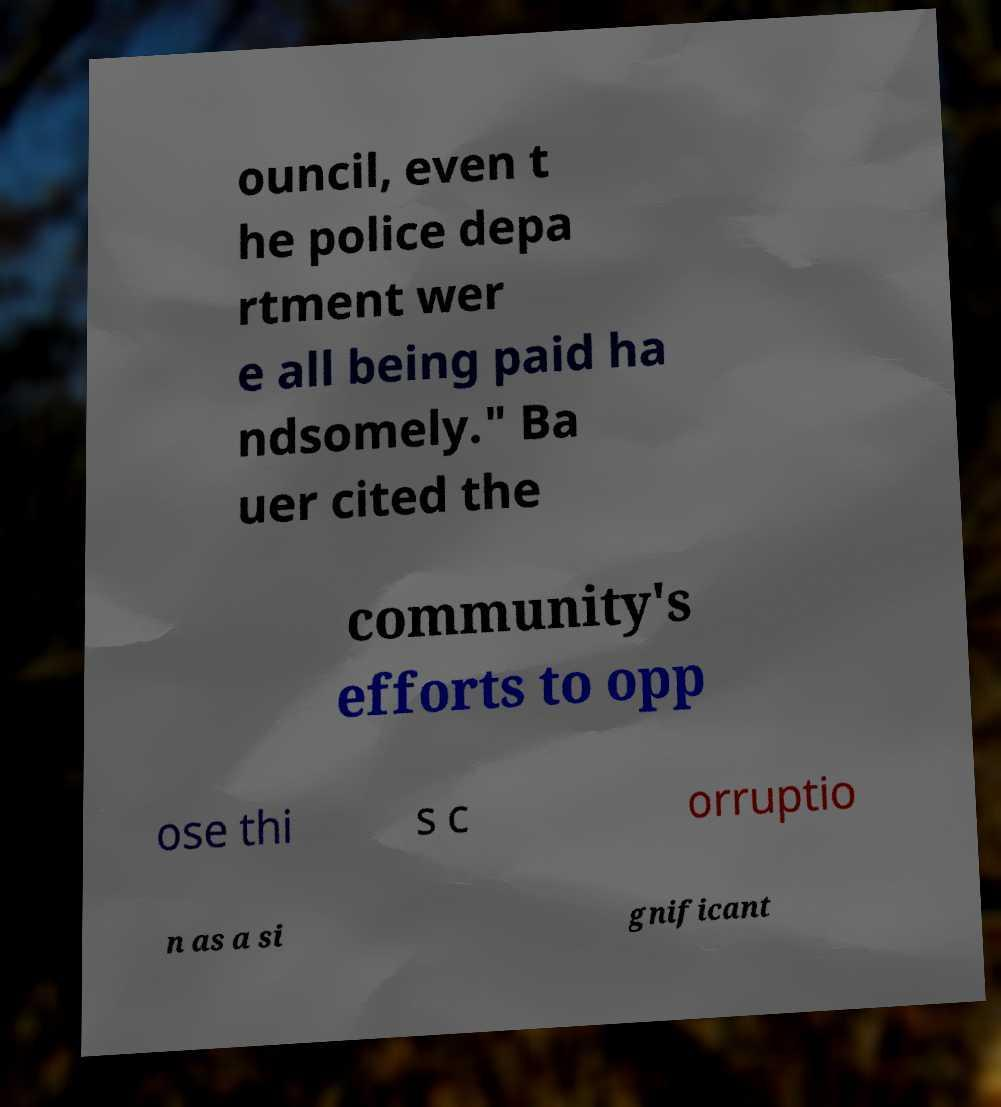I need the written content from this picture converted into text. Can you do that? ouncil, even t he police depa rtment wer e all being paid ha ndsomely." Ba uer cited the community's efforts to opp ose thi s c orruptio n as a si gnificant 